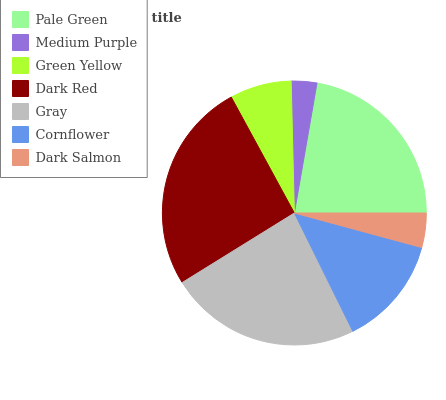Is Medium Purple the minimum?
Answer yes or no. Yes. Is Dark Red the maximum?
Answer yes or no. Yes. Is Green Yellow the minimum?
Answer yes or no. No. Is Green Yellow the maximum?
Answer yes or no. No. Is Green Yellow greater than Medium Purple?
Answer yes or no. Yes. Is Medium Purple less than Green Yellow?
Answer yes or no. Yes. Is Medium Purple greater than Green Yellow?
Answer yes or no. No. Is Green Yellow less than Medium Purple?
Answer yes or no. No. Is Cornflower the high median?
Answer yes or no. Yes. Is Cornflower the low median?
Answer yes or no. Yes. Is Green Yellow the high median?
Answer yes or no. No. Is Pale Green the low median?
Answer yes or no. No. 